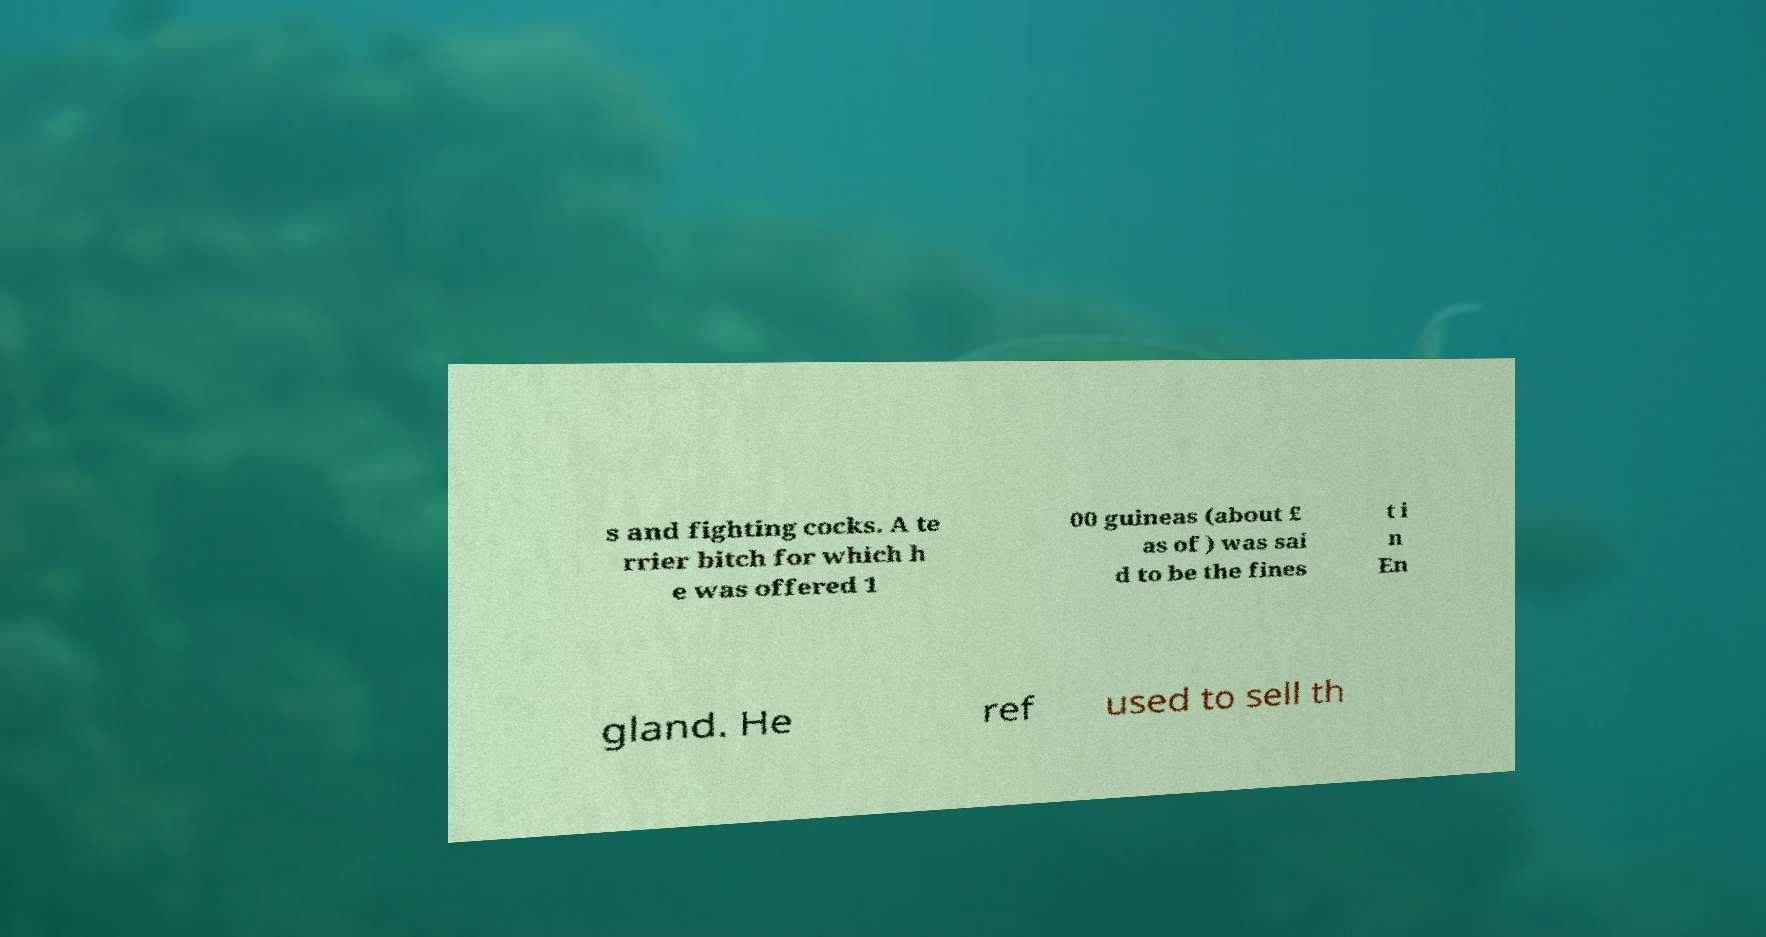Could you extract and type out the text from this image? s and fighting cocks. A te rrier bitch for which h e was offered 1 00 guineas (about £ as of ) was sai d to be the fines t i n En gland. He ref used to sell th 